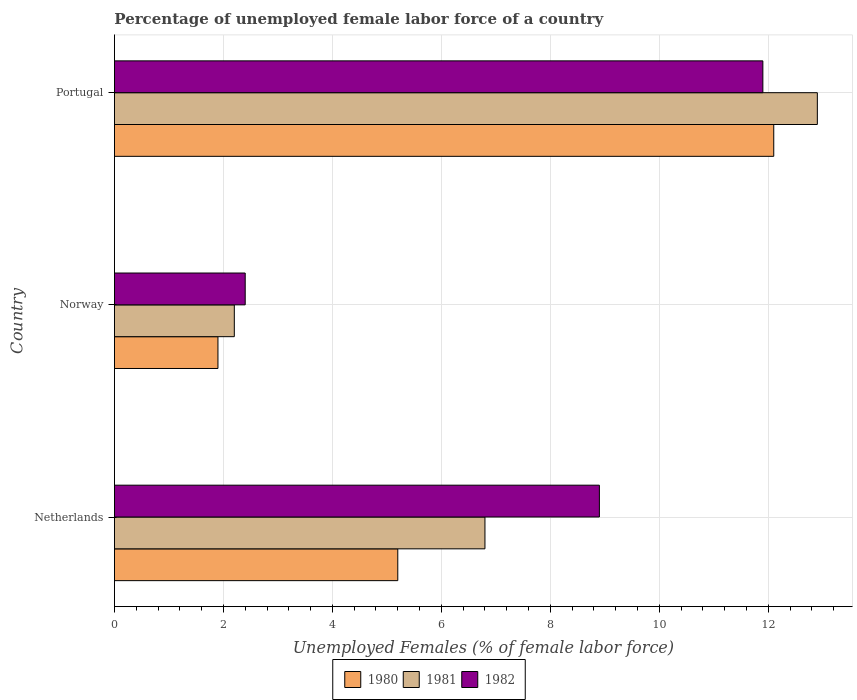How many groups of bars are there?
Ensure brevity in your answer.  3. Are the number of bars per tick equal to the number of legend labels?
Offer a very short reply. Yes. Are the number of bars on each tick of the Y-axis equal?
Offer a terse response. Yes. How many bars are there on the 1st tick from the bottom?
Offer a terse response. 3. What is the percentage of unemployed female labor force in 1980 in Portugal?
Offer a very short reply. 12.1. Across all countries, what is the maximum percentage of unemployed female labor force in 1981?
Provide a succinct answer. 12.9. Across all countries, what is the minimum percentage of unemployed female labor force in 1981?
Offer a terse response. 2.2. In which country was the percentage of unemployed female labor force in 1980 maximum?
Offer a very short reply. Portugal. In which country was the percentage of unemployed female labor force in 1982 minimum?
Offer a terse response. Norway. What is the total percentage of unemployed female labor force in 1981 in the graph?
Provide a succinct answer. 21.9. What is the difference between the percentage of unemployed female labor force in 1980 in Norway and that in Portugal?
Make the answer very short. -10.2. What is the difference between the percentage of unemployed female labor force in 1980 in Norway and the percentage of unemployed female labor force in 1982 in Portugal?
Your answer should be very brief. -10. What is the average percentage of unemployed female labor force in 1981 per country?
Your response must be concise. 7.3. What is the difference between the percentage of unemployed female labor force in 1982 and percentage of unemployed female labor force in 1980 in Portugal?
Keep it short and to the point. -0.2. In how many countries, is the percentage of unemployed female labor force in 1980 greater than 6 %?
Offer a very short reply. 1. What is the ratio of the percentage of unemployed female labor force in 1982 in Norway to that in Portugal?
Provide a short and direct response. 0.2. Is the difference between the percentage of unemployed female labor force in 1982 in Netherlands and Portugal greater than the difference between the percentage of unemployed female labor force in 1980 in Netherlands and Portugal?
Your response must be concise. Yes. What is the difference between the highest and the second highest percentage of unemployed female labor force in 1982?
Your answer should be compact. 3. What is the difference between the highest and the lowest percentage of unemployed female labor force in 1980?
Provide a short and direct response. 10.2. In how many countries, is the percentage of unemployed female labor force in 1981 greater than the average percentage of unemployed female labor force in 1981 taken over all countries?
Your answer should be very brief. 1. Is the sum of the percentage of unemployed female labor force in 1980 in Norway and Portugal greater than the maximum percentage of unemployed female labor force in 1981 across all countries?
Give a very brief answer. Yes. What does the 3rd bar from the bottom in Norway represents?
Your answer should be compact. 1982. Is it the case that in every country, the sum of the percentage of unemployed female labor force in 1982 and percentage of unemployed female labor force in 1981 is greater than the percentage of unemployed female labor force in 1980?
Your answer should be compact. Yes. How many bars are there?
Your answer should be compact. 9. Are all the bars in the graph horizontal?
Keep it short and to the point. Yes. What is the difference between two consecutive major ticks on the X-axis?
Offer a very short reply. 2. Where does the legend appear in the graph?
Keep it short and to the point. Bottom center. How many legend labels are there?
Give a very brief answer. 3. How are the legend labels stacked?
Offer a terse response. Horizontal. What is the title of the graph?
Keep it short and to the point. Percentage of unemployed female labor force of a country. What is the label or title of the X-axis?
Offer a very short reply. Unemployed Females (% of female labor force). What is the label or title of the Y-axis?
Offer a very short reply. Country. What is the Unemployed Females (% of female labor force) in 1980 in Netherlands?
Your answer should be very brief. 5.2. What is the Unemployed Females (% of female labor force) in 1981 in Netherlands?
Provide a short and direct response. 6.8. What is the Unemployed Females (% of female labor force) of 1982 in Netherlands?
Provide a short and direct response. 8.9. What is the Unemployed Females (% of female labor force) of 1980 in Norway?
Ensure brevity in your answer.  1.9. What is the Unemployed Females (% of female labor force) in 1981 in Norway?
Give a very brief answer. 2.2. What is the Unemployed Females (% of female labor force) in 1982 in Norway?
Provide a short and direct response. 2.4. What is the Unemployed Females (% of female labor force) in 1980 in Portugal?
Offer a very short reply. 12.1. What is the Unemployed Females (% of female labor force) of 1981 in Portugal?
Your answer should be very brief. 12.9. What is the Unemployed Females (% of female labor force) of 1982 in Portugal?
Offer a terse response. 11.9. Across all countries, what is the maximum Unemployed Females (% of female labor force) of 1980?
Your answer should be compact. 12.1. Across all countries, what is the maximum Unemployed Females (% of female labor force) in 1981?
Your answer should be very brief. 12.9. Across all countries, what is the maximum Unemployed Females (% of female labor force) in 1982?
Your answer should be compact. 11.9. Across all countries, what is the minimum Unemployed Females (% of female labor force) in 1980?
Provide a succinct answer. 1.9. Across all countries, what is the minimum Unemployed Females (% of female labor force) in 1981?
Offer a terse response. 2.2. Across all countries, what is the minimum Unemployed Females (% of female labor force) of 1982?
Your response must be concise. 2.4. What is the total Unemployed Females (% of female labor force) of 1980 in the graph?
Offer a very short reply. 19.2. What is the total Unemployed Females (% of female labor force) in 1981 in the graph?
Make the answer very short. 21.9. What is the total Unemployed Females (% of female labor force) of 1982 in the graph?
Your response must be concise. 23.2. What is the difference between the Unemployed Females (% of female labor force) of 1981 in Netherlands and that in Norway?
Provide a short and direct response. 4.6. What is the difference between the Unemployed Females (% of female labor force) of 1980 in Netherlands and that in Portugal?
Make the answer very short. -6.9. What is the difference between the Unemployed Females (% of female labor force) of 1980 in Norway and that in Portugal?
Provide a short and direct response. -10.2. What is the difference between the Unemployed Females (% of female labor force) of 1981 in Norway and that in Portugal?
Provide a short and direct response. -10.7. What is the difference between the Unemployed Females (% of female labor force) of 1980 in Netherlands and the Unemployed Females (% of female labor force) of 1982 in Norway?
Your response must be concise. 2.8. What is the difference between the Unemployed Females (% of female labor force) in 1980 in Netherlands and the Unemployed Females (% of female labor force) in 1981 in Portugal?
Ensure brevity in your answer.  -7.7. What is the difference between the Unemployed Females (% of female labor force) of 1981 in Netherlands and the Unemployed Females (% of female labor force) of 1982 in Portugal?
Provide a succinct answer. -5.1. What is the difference between the Unemployed Females (% of female labor force) of 1981 in Norway and the Unemployed Females (% of female labor force) of 1982 in Portugal?
Provide a succinct answer. -9.7. What is the average Unemployed Females (% of female labor force) in 1982 per country?
Your answer should be compact. 7.73. What is the difference between the Unemployed Females (% of female labor force) of 1980 and Unemployed Females (% of female labor force) of 1981 in Netherlands?
Give a very brief answer. -1.6. What is the difference between the Unemployed Females (% of female labor force) in 1981 and Unemployed Females (% of female labor force) in 1982 in Netherlands?
Offer a very short reply. -2.1. What is the difference between the Unemployed Females (% of female labor force) in 1980 and Unemployed Females (% of female labor force) in 1981 in Norway?
Your answer should be compact. -0.3. What is the difference between the Unemployed Females (% of female labor force) in 1981 and Unemployed Females (% of female labor force) in 1982 in Norway?
Make the answer very short. -0.2. What is the difference between the Unemployed Females (% of female labor force) of 1980 and Unemployed Females (% of female labor force) of 1982 in Portugal?
Offer a very short reply. 0.2. What is the ratio of the Unemployed Females (% of female labor force) of 1980 in Netherlands to that in Norway?
Keep it short and to the point. 2.74. What is the ratio of the Unemployed Females (% of female labor force) of 1981 in Netherlands to that in Norway?
Give a very brief answer. 3.09. What is the ratio of the Unemployed Females (% of female labor force) of 1982 in Netherlands to that in Norway?
Give a very brief answer. 3.71. What is the ratio of the Unemployed Females (% of female labor force) in 1980 in Netherlands to that in Portugal?
Your answer should be compact. 0.43. What is the ratio of the Unemployed Females (% of female labor force) of 1981 in Netherlands to that in Portugal?
Your answer should be very brief. 0.53. What is the ratio of the Unemployed Females (% of female labor force) of 1982 in Netherlands to that in Portugal?
Ensure brevity in your answer.  0.75. What is the ratio of the Unemployed Females (% of female labor force) in 1980 in Norway to that in Portugal?
Your answer should be compact. 0.16. What is the ratio of the Unemployed Females (% of female labor force) in 1981 in Norway to that in Portugal?
Make the answer very short. 0.17. What is the ratio of the Unemployed Females (% of female labor force) in 1982 in Norway to that in Portugal?
Give a very brief answer. 0.2. What is the difference between the highest and the second highest Unemployed Females (% of female labor force) of 1982?
Your answer should be very brief. 3. What is the difference between the highest and the lowest Unemployed Females (% of female labor force) of 1982?
Your response must be concise. 9.5. 